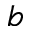Convert formula to latex. <formula><loc_0><loc_0><loc_500><loc_500>b</formula> 